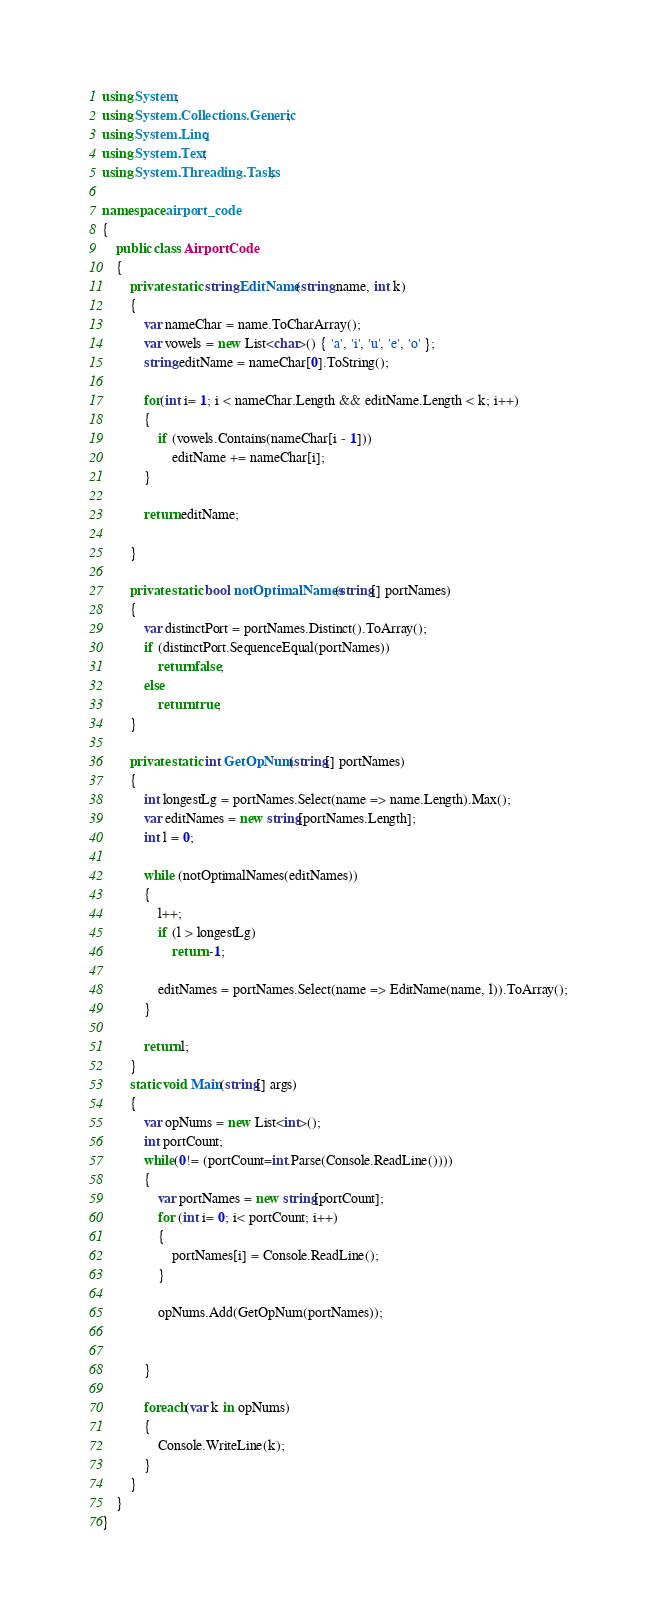<code> <loc_0><loc_0><loc_500><loc_500><_C#_>using System;
using System.Collections.Generic;
using System.Linq;
using System.Text;
using System.Threading.Tasks;

namespace airport_code
{
    public class AirportCode 
    {
        private static string EditName(string name, int k)
        {
            var nameChar = name.ToCharArray();
            var vowels = new List<char>() { 'a', 'i', 'u', 'e', 'o' };
            string editName = nameChar[0].ToString();

            for(int i= 1; i < nameChar.Length && editName.Length < k; i++)
            {
                if (vowels.Contains(nameChar[i - 1]))
                    editName += nameChar[i];
            }

            return editName;

        }

        private static bool notOptimalNames(string[] portNames)
        {
            var distinctPort = portNames.Distinct().ToArray();
            if (distinctPort.SequenceEqual(portNames))
                return false;
            else
                return true;
        }

        private static int GetOpNum(string[] portNames)
        {
            int longestLg = portNames.Select(name => name.Length).Max();
            var editNames = new string[portNames.Length];
            int l = 0;

            while (notOptimalNames(editNames))
            {
                l++;
                if (l > longestLg)
                    return -1;

                editNames = portNames.Select(name => EditName(name, l)).ToArray();
            }

            return l;
        }
        static void Main(string[] args)
        {
            var opNums = new List<int>();
            int portCount;
            while(0!= (portCount=int.Parse(Console.ReadLine())))
            {
                var portNames = new string[portCount];
                for (int i= 0; i< portCount; i++)
                {
                    portNames[i] = Console.ReadLine();
                }

                opNums.Add(GetOpNum(portNames));


            }

            foreach(var k in opNums)
            {
                Console.WriteLine(k);
            }
        }
    }
}</code> 